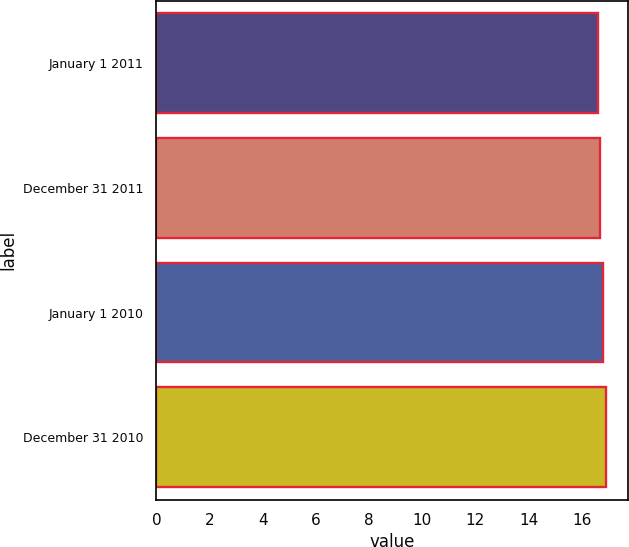Convert chart. <chart><loc_0><loc_0><loc_500><loc_500><bar_chart><fcel>January 1 2011<fcel>December 31 2011<fcel>January 1 2010<fcel>December 31 2010<nl><fcel>16.6<fcel>16.7<fcel>16.8<fcel>16.9<nl></chart> 